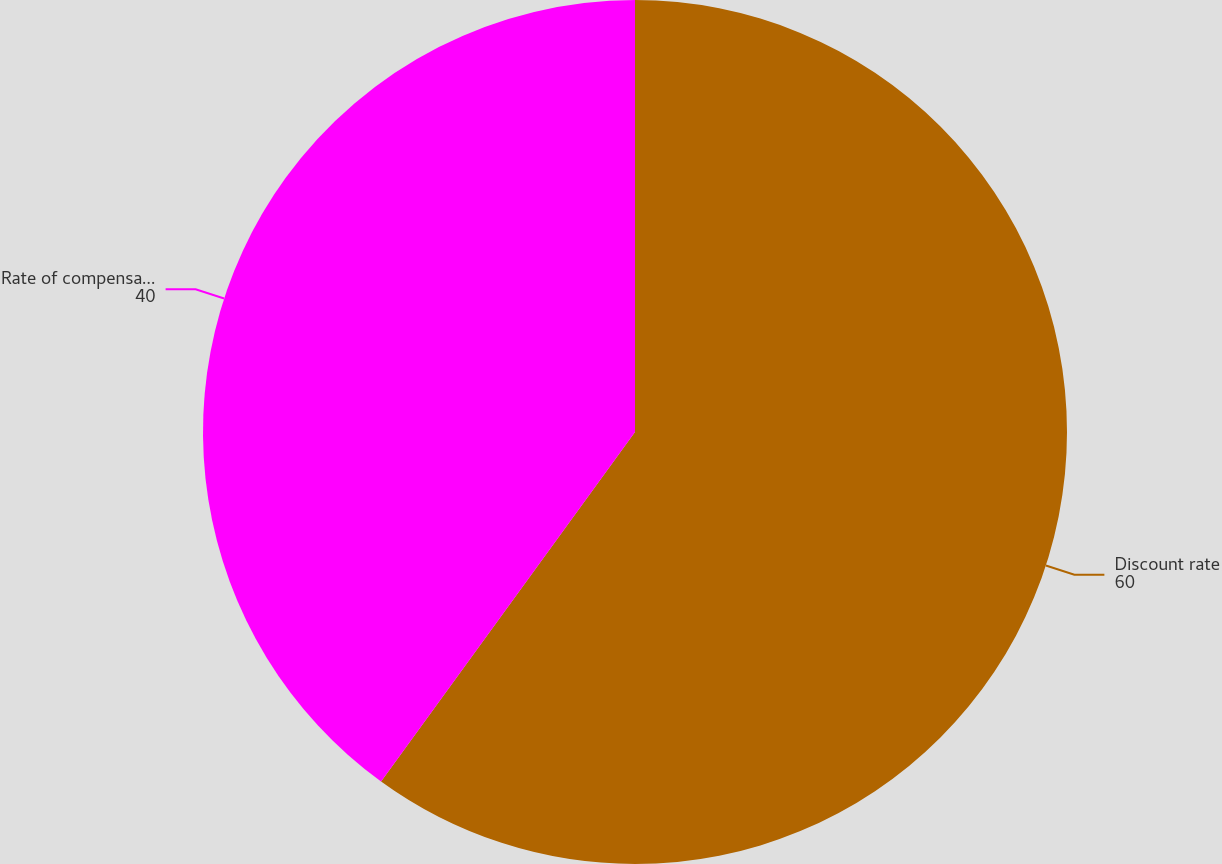Convert chart to OTSL. <chart><loc_0><loc_0><loc_500><loc_500><pie_chart><fcel>Discount rate<fcel>Rate of compensation increase<nl><fcel>60.0%<fcel>40.0%<nl></chart> 